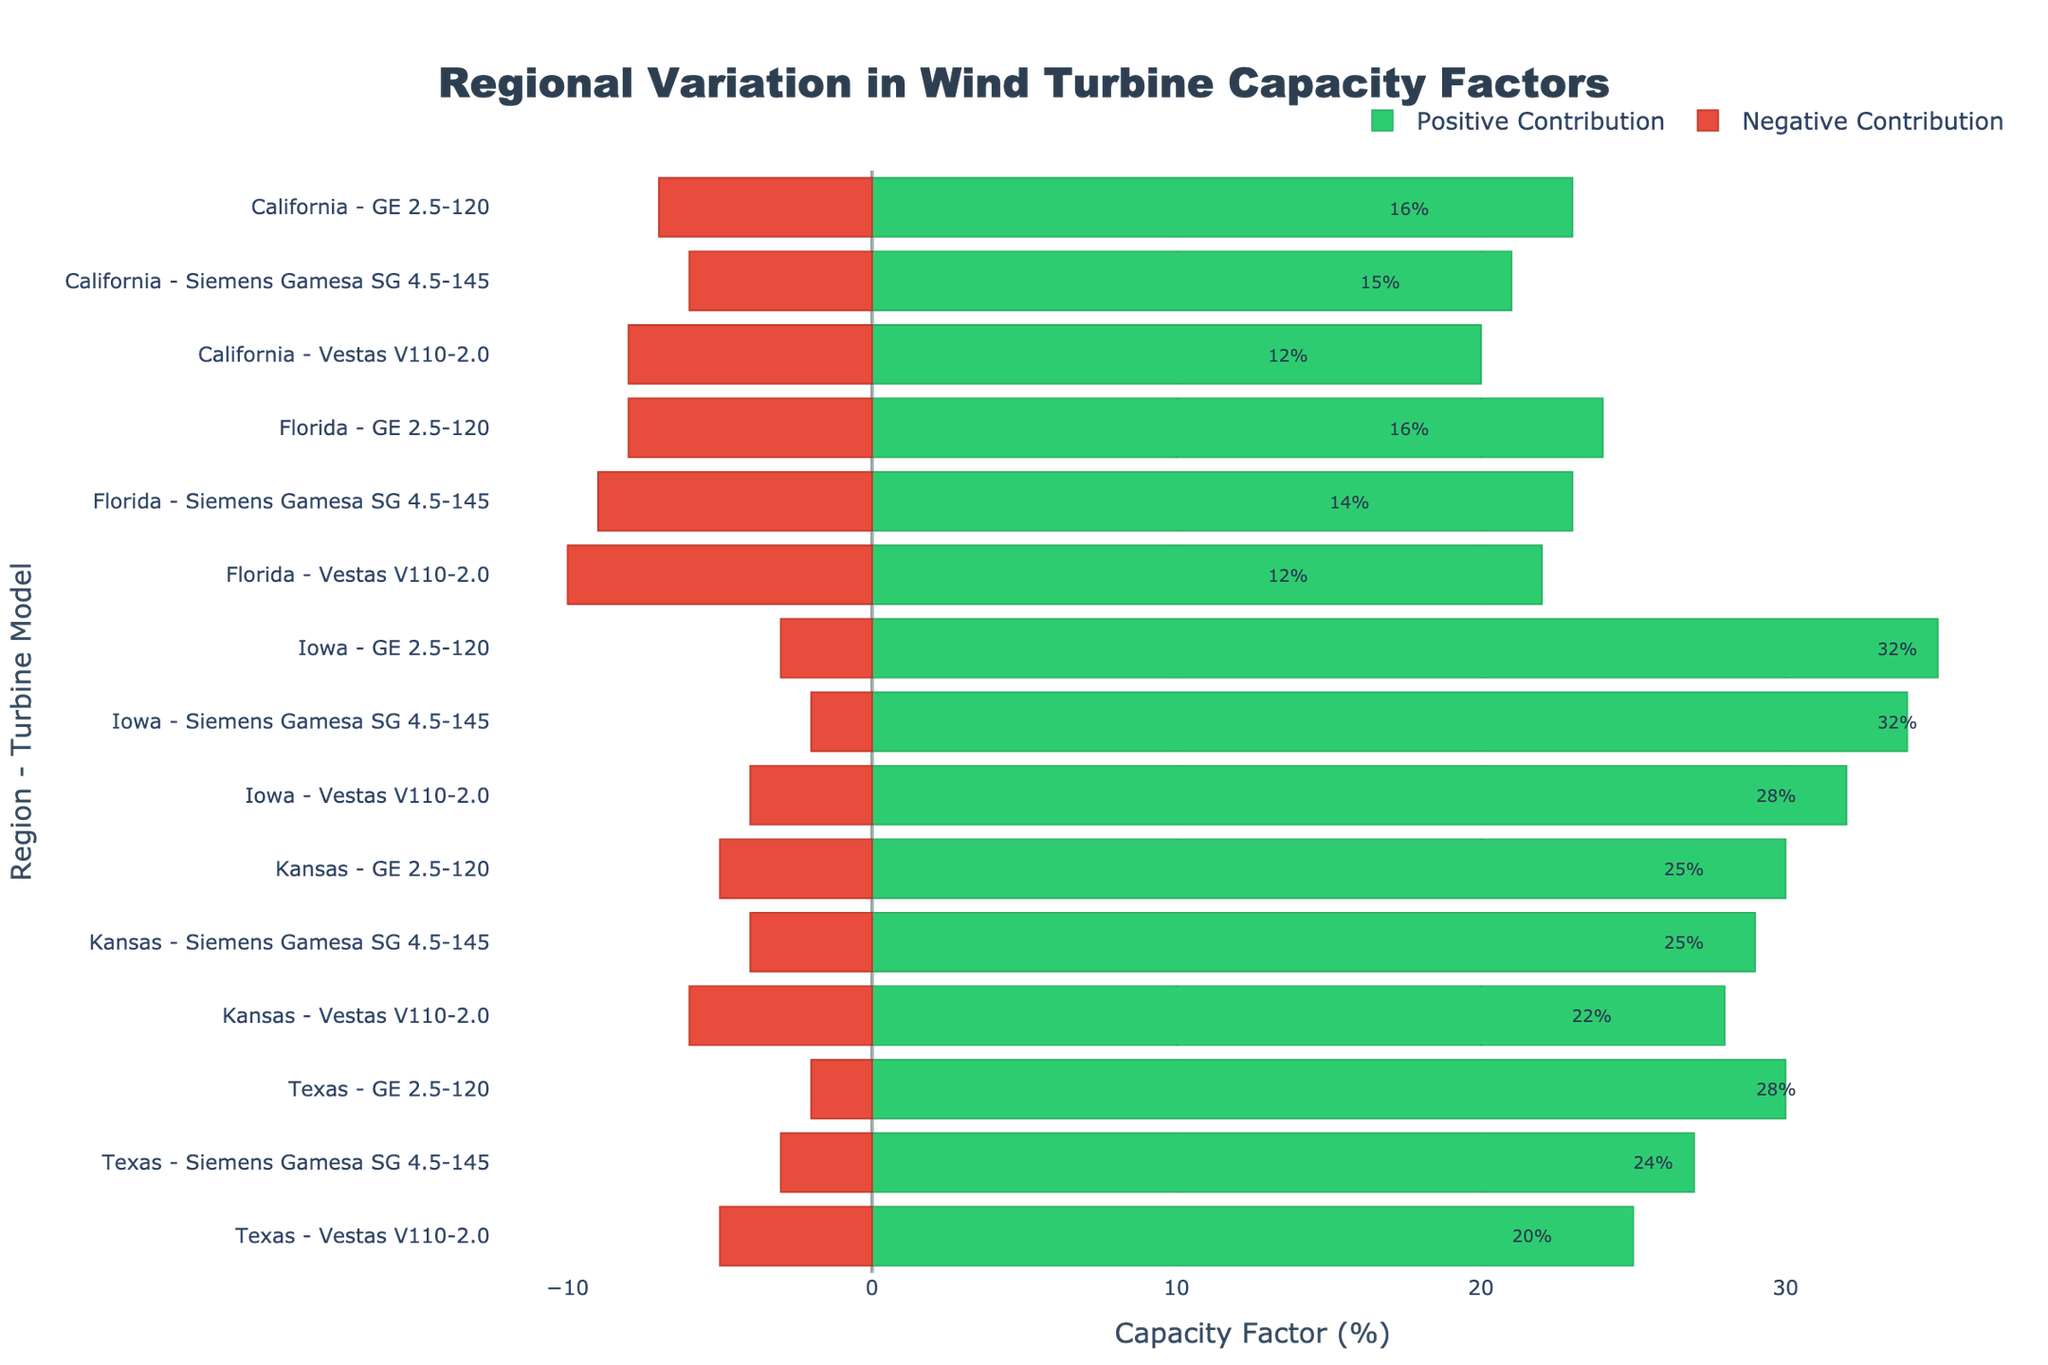What is the net capacity factor percentage for the "GE 2.5-120" model in Texas? The chart shows positive and negative contributions. For "GE 2.5-120" in Texas, the positive contribution is 30%, and the negative contribution is 2%. The net capacity factor is 30% - 2% = 28%.
Answer: 28% Which turbine model has the highest net capacity factor in Iowa? In the chart, Iowa's wind turbine models and their net capacity factors are represented. The highest values appear for "GE 2.5-120" at 32%, "Vestas V110-2.0" at 28%, and "Siemens Gamesa SG 4.5-145" at 32%. "GE 2.5-120" has the highest net capacity factor at 32%.
Answer: GE 2.5-120 Which region has the highest negative contribution for the "Vestas V110-2.0" model? By comparing the negative contributions bars for "Vestas V110-2.0" across regions, the highest negative contribution is 10% in Florida.
Answer: Florida What is the average net capacity factor of all turbine models in Texas? First, find the net capacity factor for each model in Texas. "Vestas V110-2.0" is 25% - 5% = 20%, "GE 2.5-120" is 30% - 2% = 28%, and "Siemens Gamesa SG 4.5-145" is 27% - 3% = 24%. The average is (20% + 28% + 24%) / 3 = 24%.
Answer: 24% Which turbine model in California has the smallest net contribution? By examining the net contributions in California, "Vestas V110-2.0" has 12%, "GE 2.5-120" has 16%, and "Siemens Gamesa SG 4.5-145" has 15%. The smallest net contribution is for "Vestas V110-2.0" with 12%.
Answer: Vestas V110-2.0 What is the total positive contribution for all turbine models in Kansas? In Kansas, the positive contributions are Vestas V110-2.0 = 28%, GE 2.5-120 = 30%, and Siemens Gamesa SG 4.5-145 = 29%. The total positive contributions sum up to 28% + 30% + 29% = 87%.
Answer: 87% What is the difference between the highest and lowest net capacity factors across all models in Texas? For Texas, the highest is "GE 2.5-120" at 28%, and the lowest is "Vestas V110-2.0" at 20%. The difference is 28% - 20% = 8%.
Answer: 8% Which region has the overall highest average net capacity factor? By comparing the average net capacity factors: Texas = (20% + 28% + 24%) / 3 = 24%, California = (12% + 16% + 15%) / 3 = 14.33%, Iowa = (28% + 32% + 32%)/3 = 30.67%, Kansas = (22% + 25% + 25%) / 3 = 24%, and Florida = (12% + 16% + 14%) / 3 = 14%. Iowa has the overall highest average at 30.67%.
Answer: Iowa 